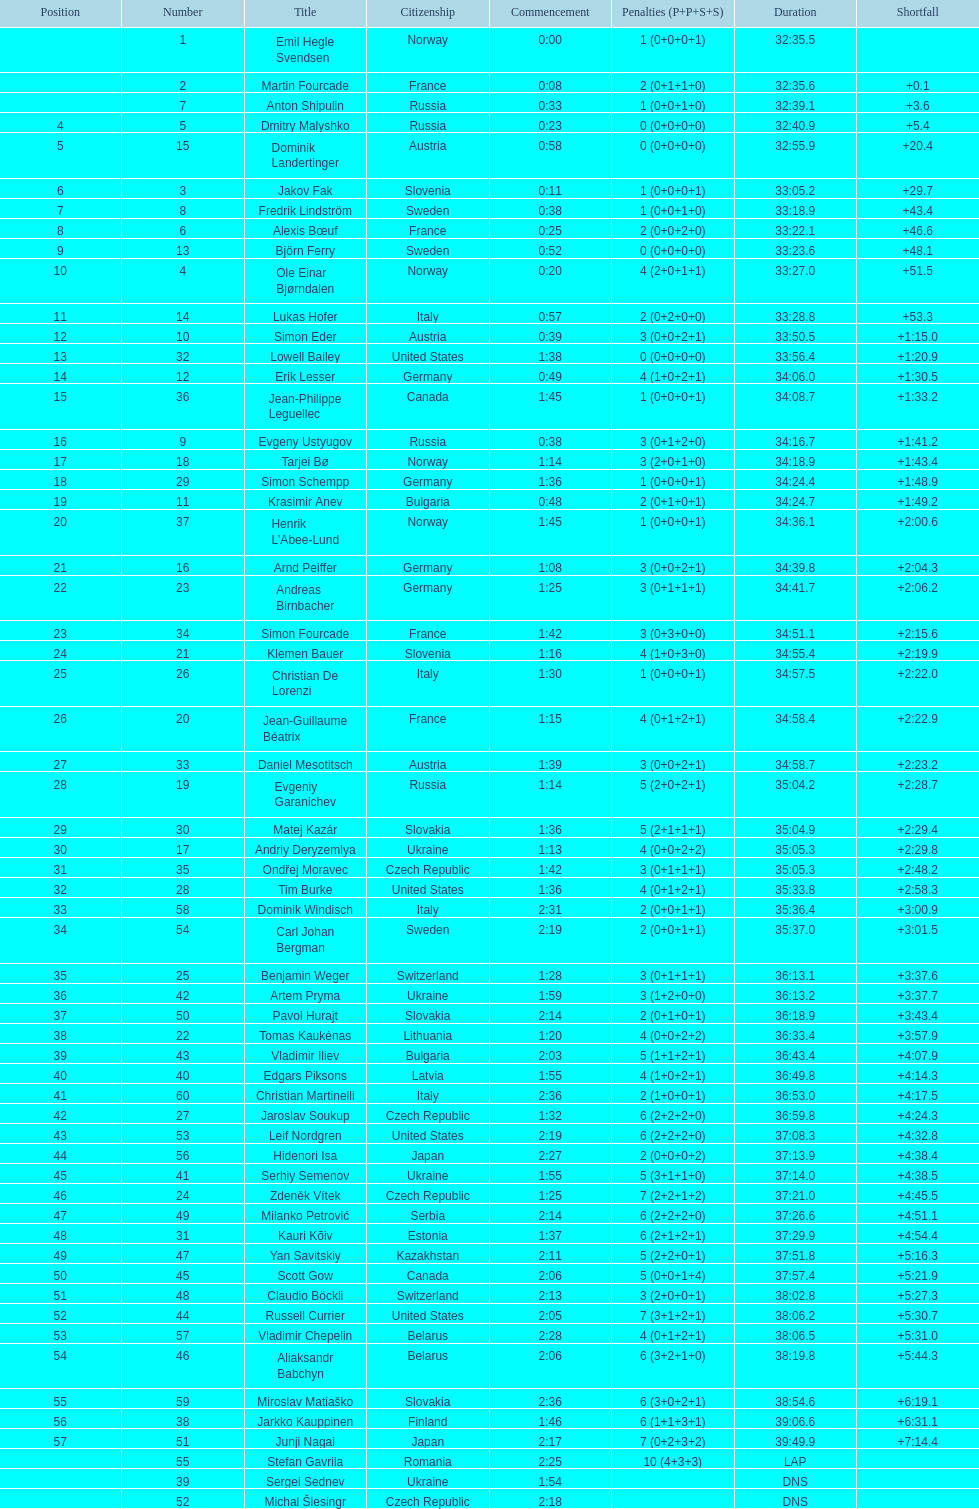How many people completed in a minimum of 35:00? 30. 